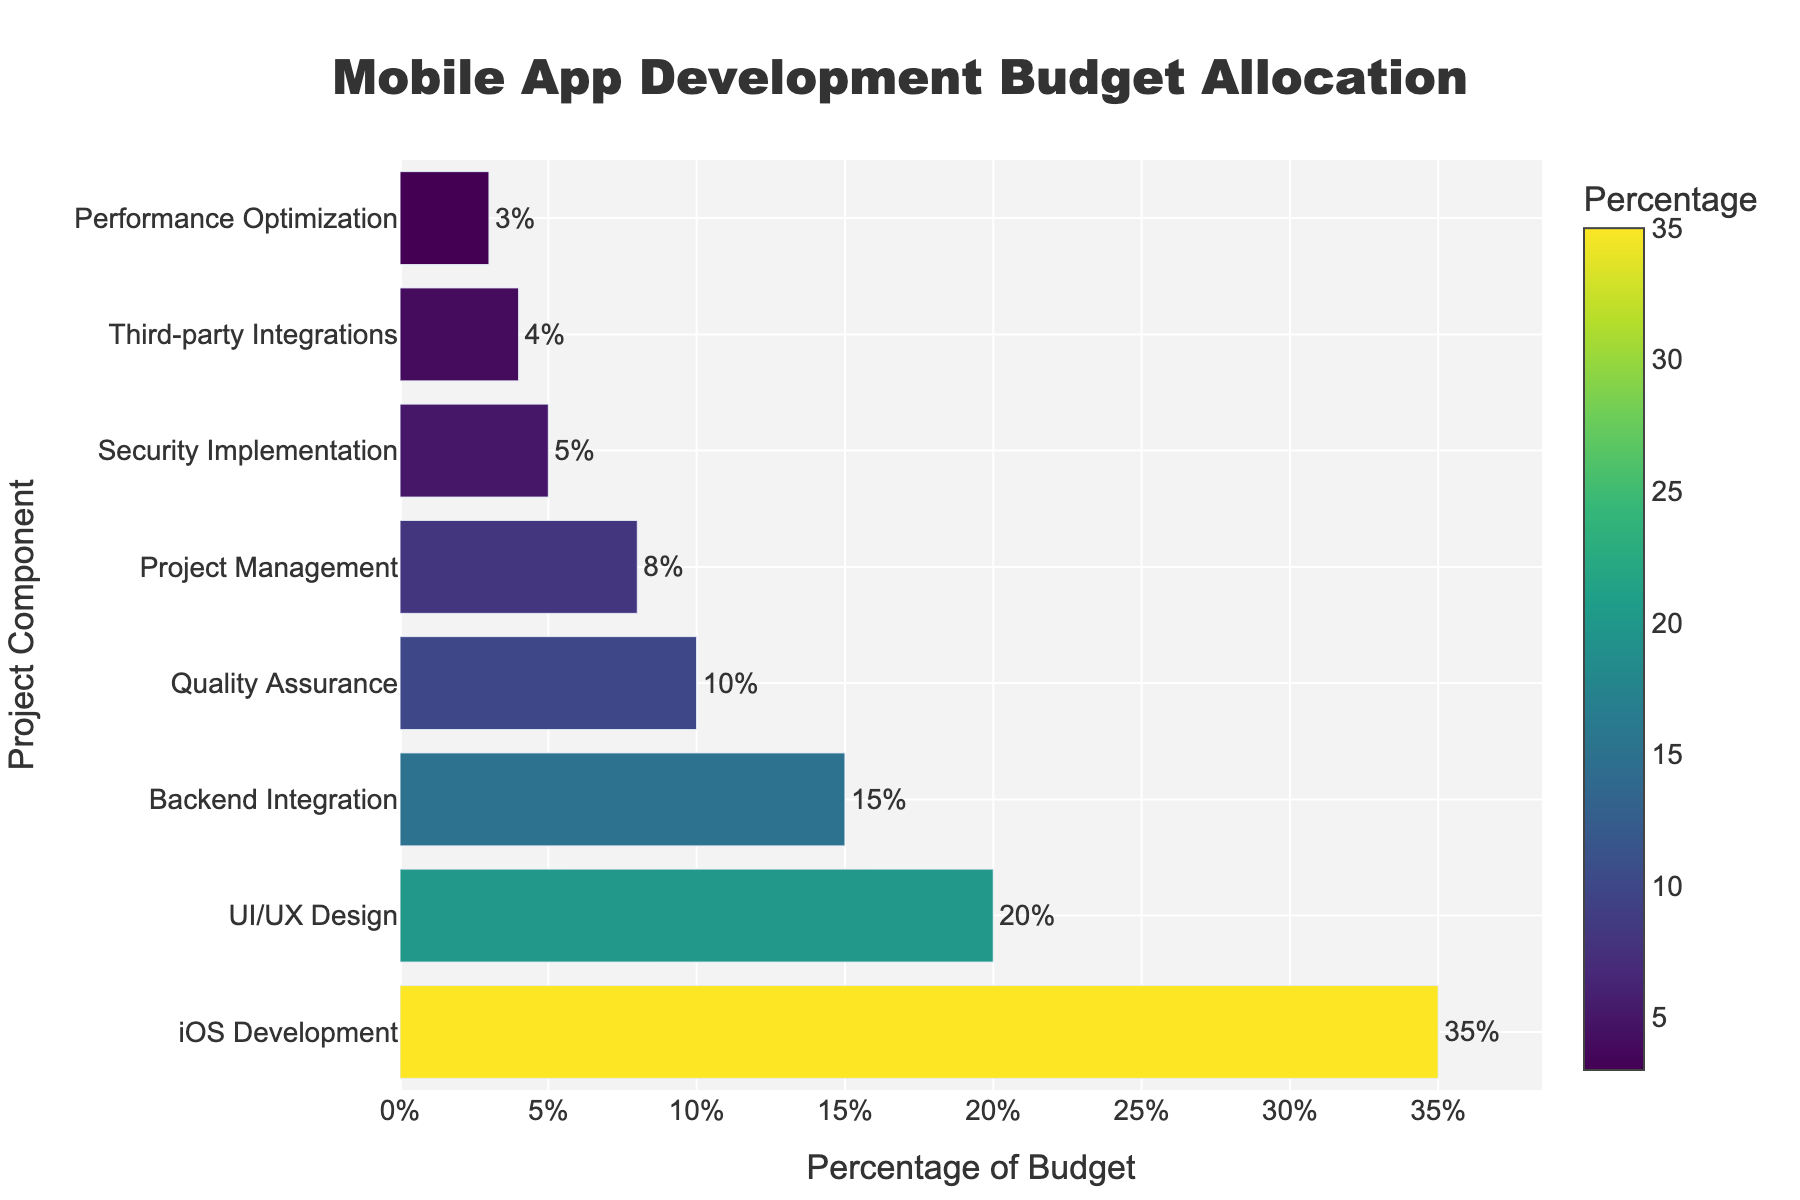What is the component with the highest budget allocation? By observing the bar chart, the bar corresponding to "iOS Development" is the longest. It indicates the highest percentage.
Answer: iOS Development Which component has a higher budget allocation, Backend Integration or QA? Compare the lengths of the bars for "Backend Integration" (15%) and "Quality Assurance" (10%). The bar for Backend Integration is longer.
Answer: Backend Integration How much more budget percentage is allocated to UI/UX Design than Performance Optimization? Subtract the percentage of Performance Optimization (3%) from UI/UX Design (20%). 20% - 3% = 17%.
Answer: 17% What is the total budget percentage for Security Implementation and Third-party Integrations combined? Add the percentages of Security Implementation (5%) and Third-party Integrations (4%). 5% + 4% = 9%.
Answer: 9% What component has the lowest budget allocation? By observing the shortest bar in the chart, it corresponds to "Performance Optimization" with a 3% allocation.
Answer: Performance Optimization Which components have a budget allocation of less than 10%? Identify all components with bars shorter than the 10% mark: "Project Management" (8%), "Security Implementation" (5%), "Third-party Integrations" (4%), and "Performance Optimization" (3%).
Answer: Project Management, Security Implementation, Third-party Integrations, Performance Optimization What is the average budget allocation for the listed components? Add all the percentages and divide by the number of components: (20% + 35% + 15% + 10% + 8% + 5% + 4% + 3%) / 8. Total = 100% / 8 = 12.5%.
Answer: 12.5% How much more budget is allocated to iOS Development compared to Project Management? Subtract the percentage of Project Management (8%) from iOS Development (35%). 35% - 8% = 27%.
Answer: 27% Which has a larger budget, Quality Assurance or Security Implementation and Third-party Integrations combined? Compare Quality Assurance (10%) with the combined total of Security Implementation and Third-party Integrations (5% + 4% = 9%). Quality Assurance (10%) is larger.
Answer: Quality Assurance What is the combined budget percentage for non-development components (exclude iOS Development and Backend Integration)? Add the percentages for UI/UX Design, Quality Assurance, Project Management, Security Implementation, Third-party Integrations, and Performance Optimization: 20% + 10% + 8% + 5% + 4% + 3% = 50%.
Answer: 50% 